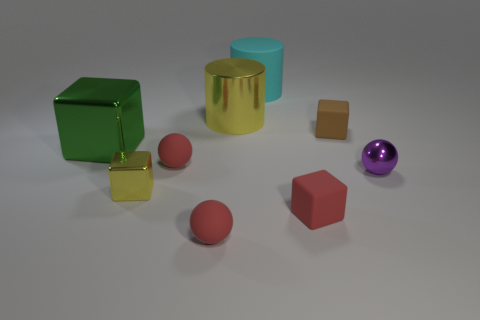There is a metal cube that is to the left of the yellow block; what size is it?
Offer a terse response. Large. Is the yellow metal cylinder the same size as the brown matte cube?
Your answer should be compact. No. There is a small red matte object that is on the right side of the big cyan matte thing; is its shape the same as the tiny metallic object left of the big cyan rubber cylinder?
Offer a very short reply. Yes. There is a rubber block that is to the left of the brown block; are there any purple balls behind it?
Your answer should be compact. Yes. Are there any large blue balls?
Your response must be concise. No. What number of green metallic objects have the same size as the purple shiny ball?
Provide a succinct answer. 0. What number of large metal things are both to the right of the green metallic object and in front of the large yellow object?
Make the answer very short. 0. Does the rubber block that is behind the yellow metal cube have the same size as the large yellow object?
Offer a very short reply. No. Is there a cylinder that has the same color as the tiny metallic block?
Your response must be concise. Yes. There is a cyan object that is the same material as the tiny brown cube; what is its size?
Your response must be concise. Large. 